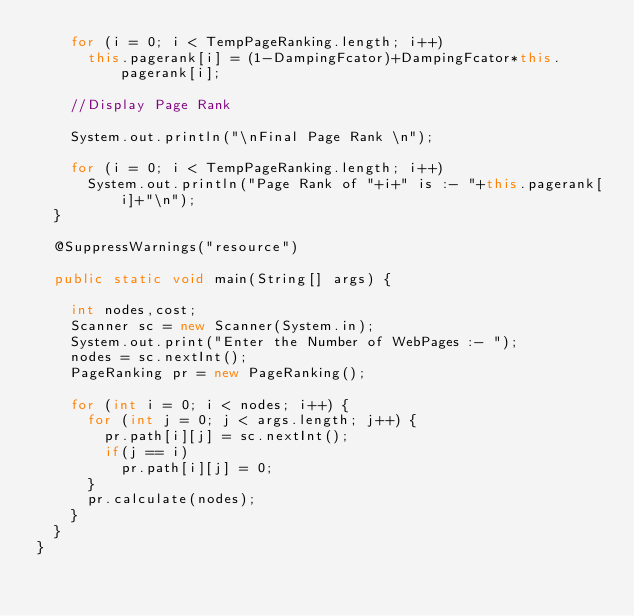<code> <loc_0><loc_0><loc_500><loc_500><_Java_>		for (i = 0; i < TempPageRanking.length; i++) 
			this.pagerank[i] = (1-DampingFcator)+DampingFcator*this.pagerank[i];
		
		//Display Page Rank
		
		System.out.println("\nFinal Page Rank \n");
		
		for (i = 0; i < TempPageRanking.length; i++) 
			System.out.println("Page Rank of "+i+" is :- "+this.pagerank[i]+"\n");
	}
	
	@SuppressWarnings("resource")
	
	public static void main(String[] args) {
		
		int nodes,cost;
		Scanner sc = new Scanner(System.in);
		System.out.print("Enter the Number of WebPages :- ");
		nodes = sc.nextInt();
		PageRanking pr = new PageRanking();
		
		for (int i = 0; i < nodes; i++) {
			for (int j = 0; j < args.length; j++) {
				pr.path[i][j] = sc.nextInt();
				if(j == i)
					pr.path[i][j] = 0;
			}
			pr.calculate(nodes);
		}
	}
}
</code> 